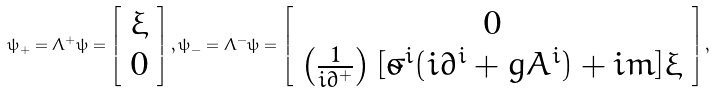Convert formula to latex. <formula><loc_0><loc_0><loc_500><loc_500>\psi _ { + } = \Lambda ^ { + } \psi = \left [ \begin{array} { l } \xi \\ 0 \end{array} \right ] , \psi _ { - } = \Lambda ^ { - } \psi = \left [ \begin{array} { c } 0 \\ \left ( \frac { 1 } { i \partial ^ { + } } \right ) [ \tilde { \sigma } ^ { i } ( i \partial ^ { i } + g A ^ { i } ) + i m ] \xi \end{array} \right ] ,</formula> 